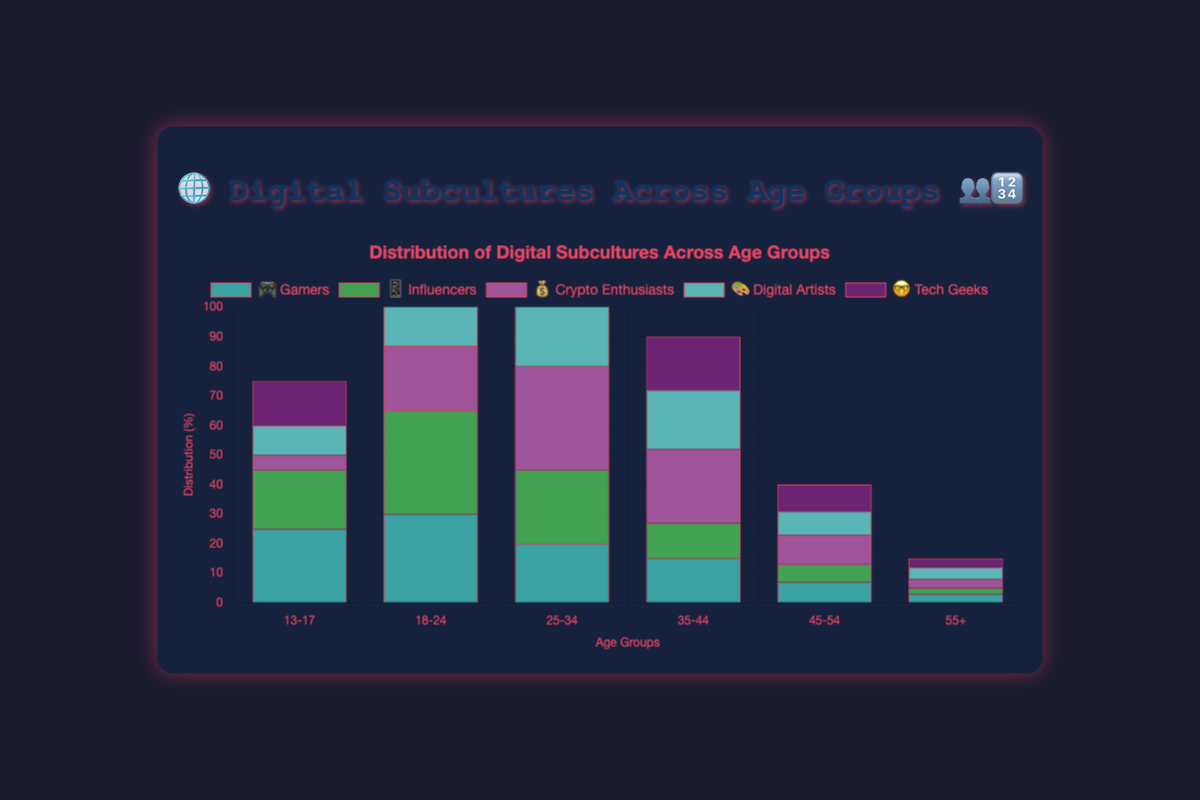What is the title of the chart? The title is positioned at the top and clearly states the topic.
Answer: 🌐 Digital Subcultures Across Age Groups 👥🔢 Which age group has the highest representation of Gamers 🎮? Looking at the chart, the "Gamers" bar is tallest for the "18-24" age group.
Answer: 18-24 What is the combined distribution percentage of Influencers 📱 in the 18-24 and 25-34 age groups? The Influencer distribution in the "18-24" group is 35% and in the "25-34" group is 25%. Adding these together gives 35 + 25 = 60.
Answer: 60% Which subculture has the least representation in the 55+ age group? Examining the bars for the "55+" age group, the shortest bar corresponds to "Influencers," at 2%.
Answer: Influencers 📱 Among 25-34-year-olds, which two subcultures have the closest distribution percentages, and what are those percentages? For the "25-34" age group, "Gamers" and "Digital Artists" have the closest distribution percentages, 20% and 30%, with a difference of 10%.
Answer: Gamers 🎮 (20%) and Digital Artists 🎨 (30%) Compare the Crypto Enthusiasts' 💰 distribution in the 18-24 and 45-54 age groups, and find the difference. In the chart, the Crypto Enthusiasts' distribution is 22% for the "18-24" age group and 10% for the "45-54" age group. The difference is 22 - 10 = 12.
Answer: 12% For age group 35-44, which digital subculture is most prevalent? Observing the "35-44" age group, the tallest bar represents "Crypto Enthusiasts" at 25%.
Answer: Crypto Enthusiasts 💰 What is the total representation of Tech Geeks 🤓 across all age groups? Adding Tech Geeks' distribution across all age groups: 15 + 25 + 30 + 18 + 9 + 3 = 100.
Answer: 100% In which age group do Digital Artists 🎨 show the highest distribution? For "Digital Artists," the "25-34" age group has the tallest bar, indicating the highest distribution.
Answer: 25-34 Do Influencers 📱 have a higher distribution than Gamers 🎮 in the 25-34 age group, and by how much? In the "25-34" age group, Influencers have a distribution of 25%, and Gamers have 20%. The difference is 25 - 20 = 5.
Answer: Yes, by 5% 